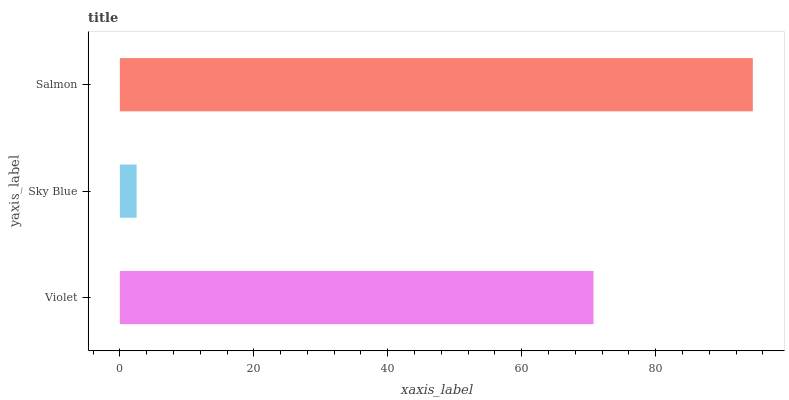Is Sky Blue the minimum?
Answer yes or no. Yes. Is Salmon the maximum?
Answer yes or no. Yes. Is Salmon the minimum?
Answer yes or no. No. Is Sky Blue the maximum?
Answer yes or no. No. Is Salmon greater than Sky Blue?
Answer yes or no. Yes. Is Sky Blue less than Salmon?
Answer yes or no. Yes. Is Sky Blue greater than Salmon?
Answer yes or no. No. Is Salmon less than Sky Blue?
Answer yes or no. No. Is Violet the high median?
Answer yes or no. Yes. Is Violet the low median?
Answer yes or no. Yes. Is Sky Blue the high median?
Answer yes or no. No. Is Sky Blue the low median?
Answer yes or no. No. 